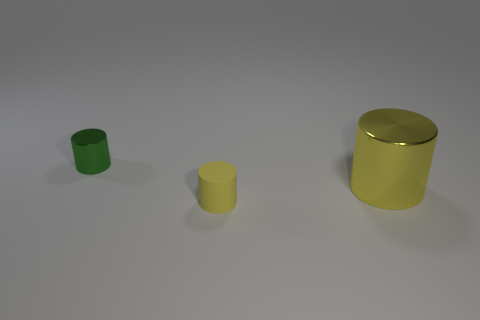Is there anything else that has the same size as the yellow metallic object?
Offer a terse response. No. What number of metal objects are either gray things or small green objects?
Your answer should be compact. 1. Is there a shiny cylinder that has the same size as the yellow matte thing?
Provide a succinct answer. Yes. Are there more tiny green shiny cylinders that are in front of the yellow rubber thing than large shiny objects?
Provide a succinct answer. No. How many big objects are either metallic things or yellow rubber cylinders?
Keep it short and to the point. 1. What number of other yellow things are the same shape as the yellow matte object?
Keep it short and to the point. 1. What material is the yellow cylinder that is right of the small yellow rubber thing in front of the tiny green shiny cylinder?
Make the answer very short. Metal. What is the size of the shiny thing left of the small yellow rubber object?
Your response must be concise. Small. What number of purple things are either tiny cylinders or big metal cylinders?
Offer a terse response. 0. Is there any other thing that has the same material as the tiny yellow thing?
Keep it short and to the point. No. 